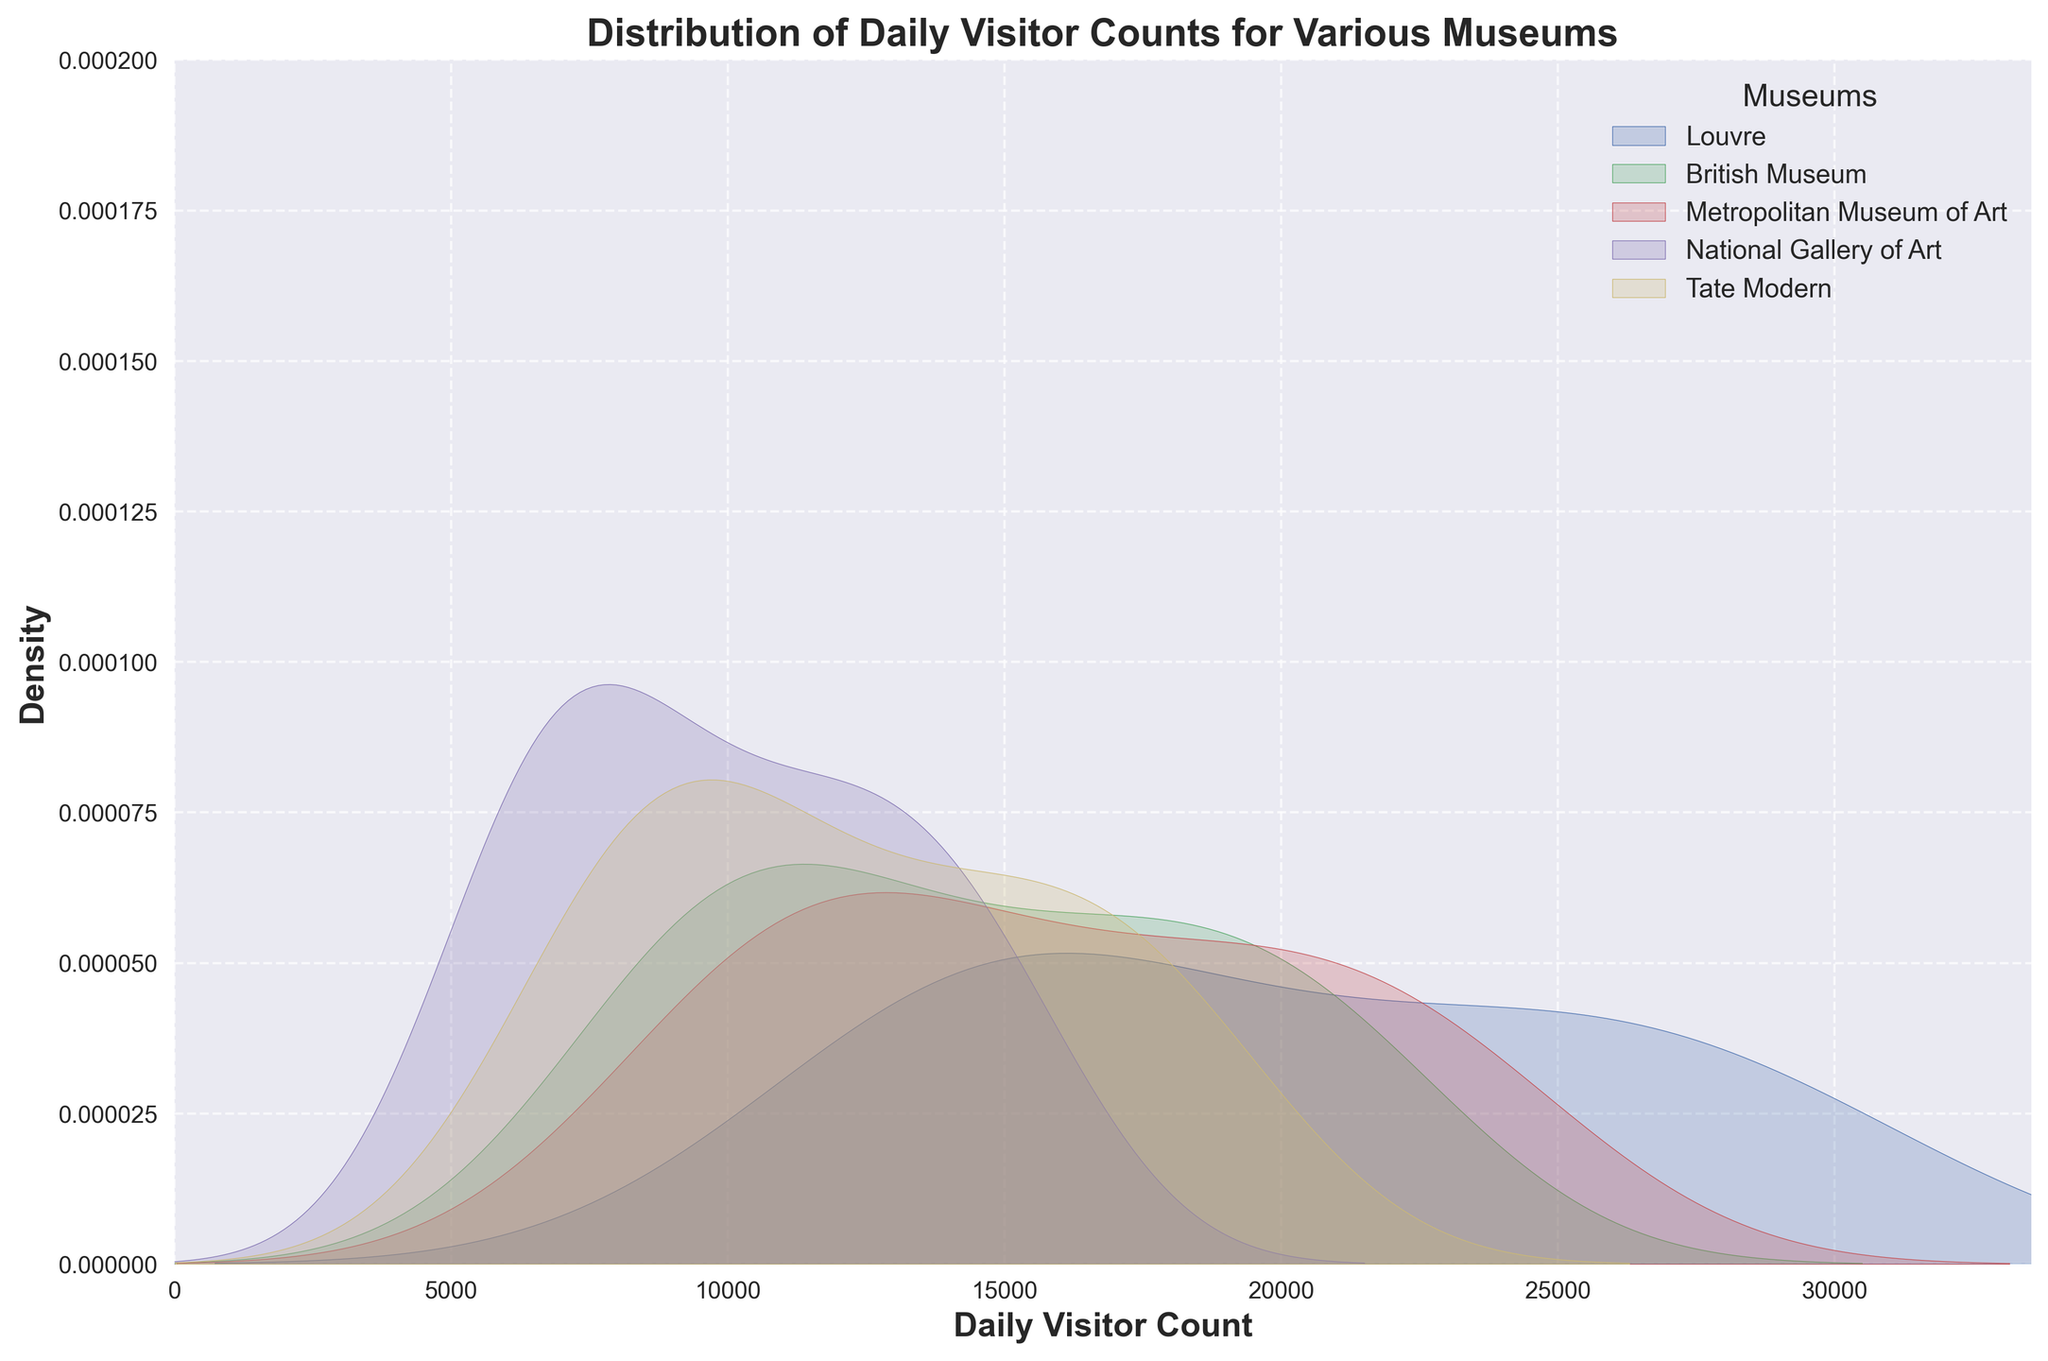What is the title of the figure? The title of the figure is usually found at the top of the plot and is intended to provide a summary of what the plot represents. In this case, we can see it highlighting the subject of the visual data.
Answer: Distribution of Daily Visitor Counts for Various Museums Which museum has the widest distribution of daily visitor counts? To determine the museum with the widest distribution, look at the spread of each density plot. A wider curve represents a wider distribution.
Answer: Louvre Which month seems to have the highest visitor density for most museums? To ascertain the month, observe the peak areas under the density plots. Higher peaks at certain values indicate higher densities.
Answer: August Are the seasonal trends similar across all museums? Analyzing the graphs, we can see if the peaks and valleys of the density plots occur at similar times of the year for all museums, indicating similar trends or not.
Answer: Yes Which museum has the narrowest distribution of daily visitor counts throughout the year? Look for the museum whose density plot has the narrowest range between its minimum and maximum daily visitor count, indicated by a steeper curve.
Answer: Tate Modern How do the visitor counts at the Louvre and Tate Modern compare in the summer months? Compare the density plots of the Louvre and Tate Modern by observing their values in the region corresponding to summer, June to August, to see which has higher densities.
Answer: Louvre has higher counts What is the range of daily visitor counts covered for the British Museum? The range can be estimated by looking at where the British Museum's density curve starts and ends along the x-axis.
Answer: Approximately 8500 to 22000 Which museum experiences the least variation in daily visitor counts? The museum with the least variation in visitor counts will have a denser and more peaked density plot, indicating values are closely clustered.
Answer: Tate Modern How does the density of visitors in March compare between the National Gallery of Art and the Metropolitan Museum of Art? Find the peaks on the density plots around the range corresponding to March and compare the densities (heights) for the National Gallery of Art and Metropolitan Museum of Art.
Answer: Metropolitan Museum of Art has higher visitor density What trend can be observed in daily visitor counts at the Louvre during the summer months? Observe the density plot curve for the Louvre around the x-axis values corresponding to the summer months to identify any upward or downward trends.
Answer: Increasing trend 